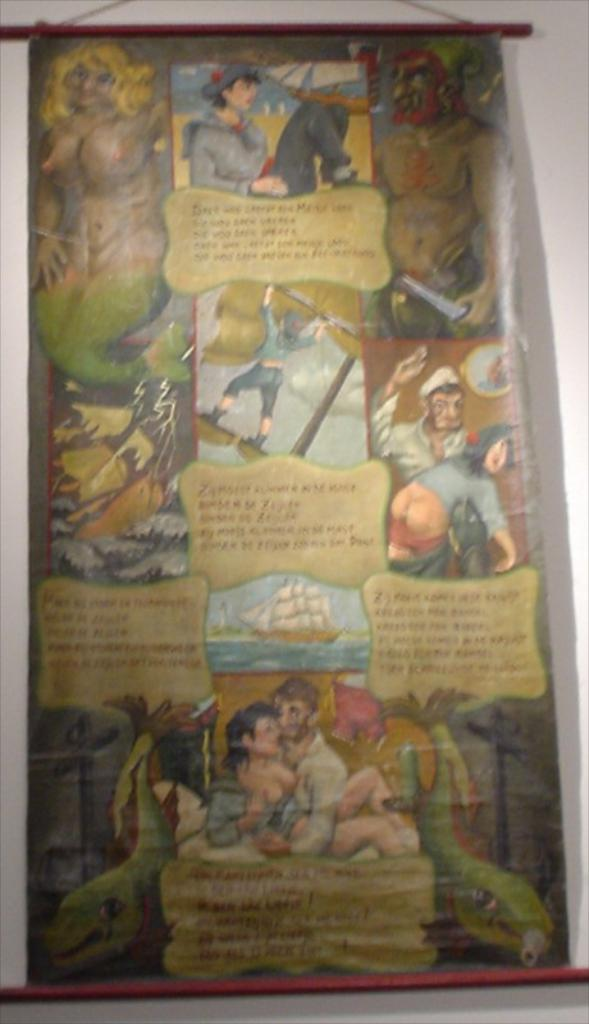What is present on the poster in the image? There is a poster in the image. What can be found on the poster besides the poster itself? The poster contains different images and descriptions of those images. How many zippers are visible on the poster in the image? There are no zippers present on the poster in the image. 